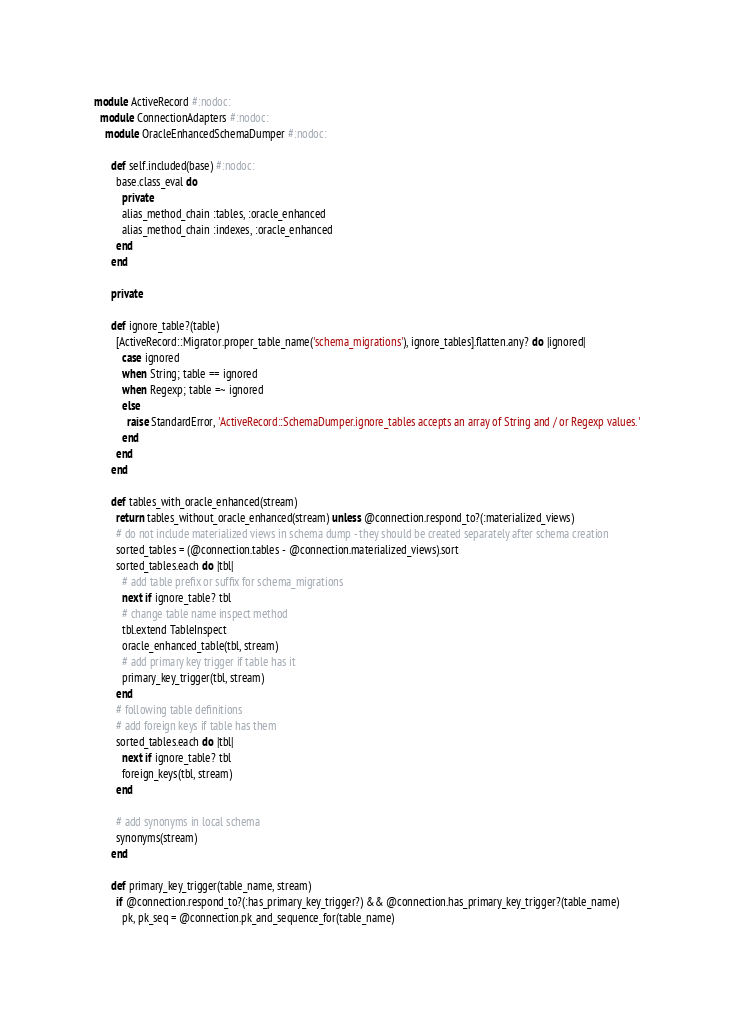<code> <loc_0><loc_0><loc_500><loc_500><_Ruby_>module ActiveRecord #:nodoc:
  module ConnectionAdapters #:nodoc:
    module OracleEnhancedSchemaDumper #:nodoc:

      def self.included(base) #:nodoc:
        base.class_eval do
          private
          alias_method_chain :tables, :oracle_enhanced
          alias_method_chain :indexes, :oracle_enhanced
        end
      end

      private

      def ignore_table?(table)
        [ActiveRecord::Migrator.proper_table_name('schema_migrations'), ignore_tables].flatten.any? do |ignored|
          case ignored
          when String; table == ignored
          when Regexp; table =~ ignored
          else
            raise StandardError, 'ActiveRecord::SchemaDumper.ignore_tables accepts an array of String and / or Regexp values.'
          end
        end
      end

      def tables_with_oracle_enhanced(stream)
        return tables_without_oracle_enhanced(stream) unless @connection.respond_to?(:materialized_views)
        # do not include materialized views in schema dump - they should be created separately after schema creation
        sorted_tables = (@connection.tables - @connection.materialized_views).sort
        sorted_tables.each do |tbl|
          # add table prefix or suffix for schema_migrations
          next if ignore_table? tbl
          # change table name inspect method
          tbl.extend TableInspect
          oracle_enhanced_table(tbl, stream)
          # add primary key trigger if table has it
          primary_key_trigger(tbl, stream)
        end
        # following table definitions
        # add foreign keys if table has them
        sorted_tables.each do |tbl|
          next if ignore_table? tbl
          foreign_keys(tbl, stream)
        end

        # add synonyms in local schema
        synonyms(stream)
      end

      def primary_key_trigger(table_name, stream)
        if @connection.respond_to?(:has_primary_key_trigger?) && @connection.has_primary_key_trigger?(table_name)
          pk, pk_seq = @connection.pk_and_sequence_for(table_name)</code> 